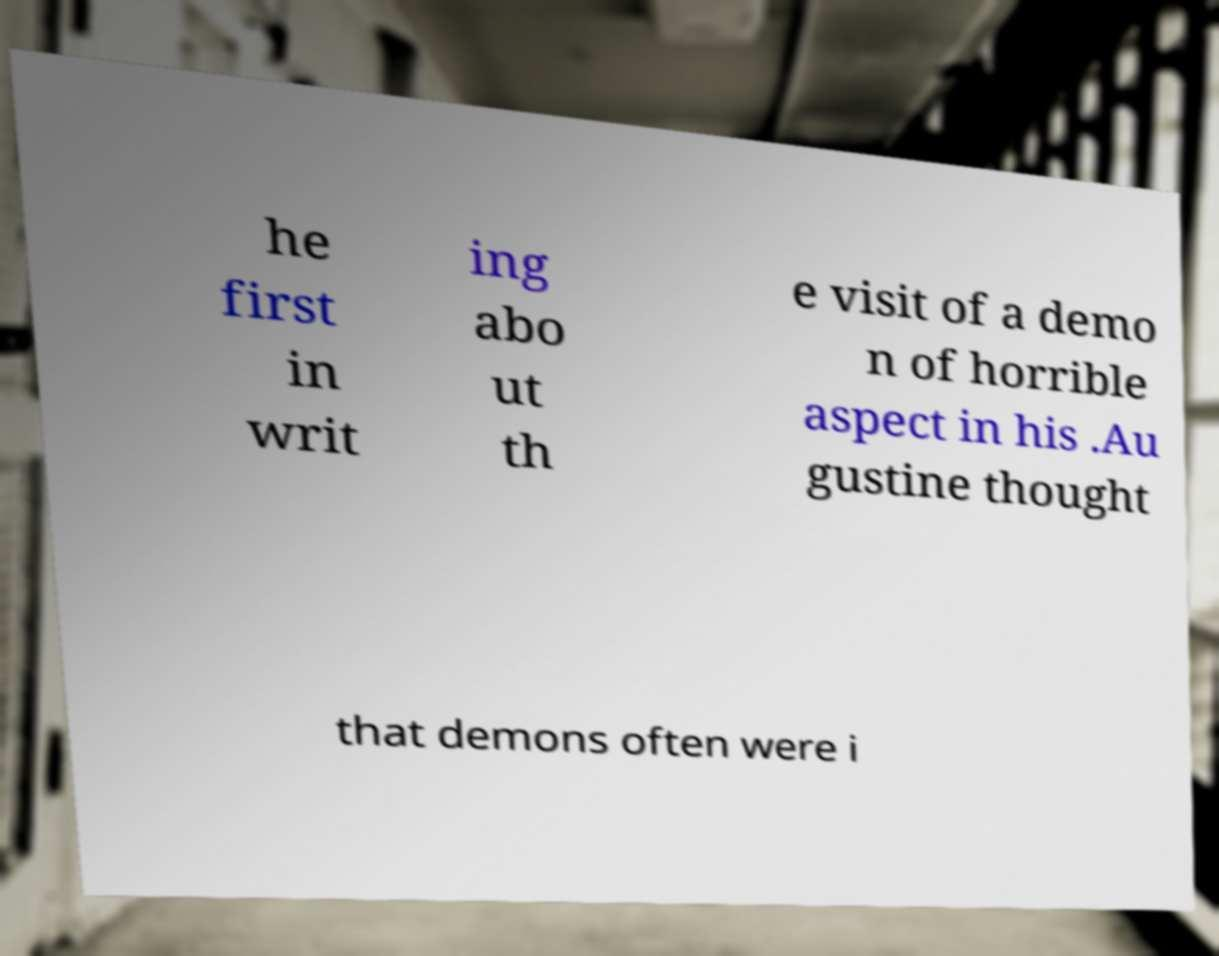I need the written content from this picture converted into text. Can you do that? he first in writ ing abo ut th e visit of a demo n of horrible aspect in his .Au gustine thought that demons often were i 